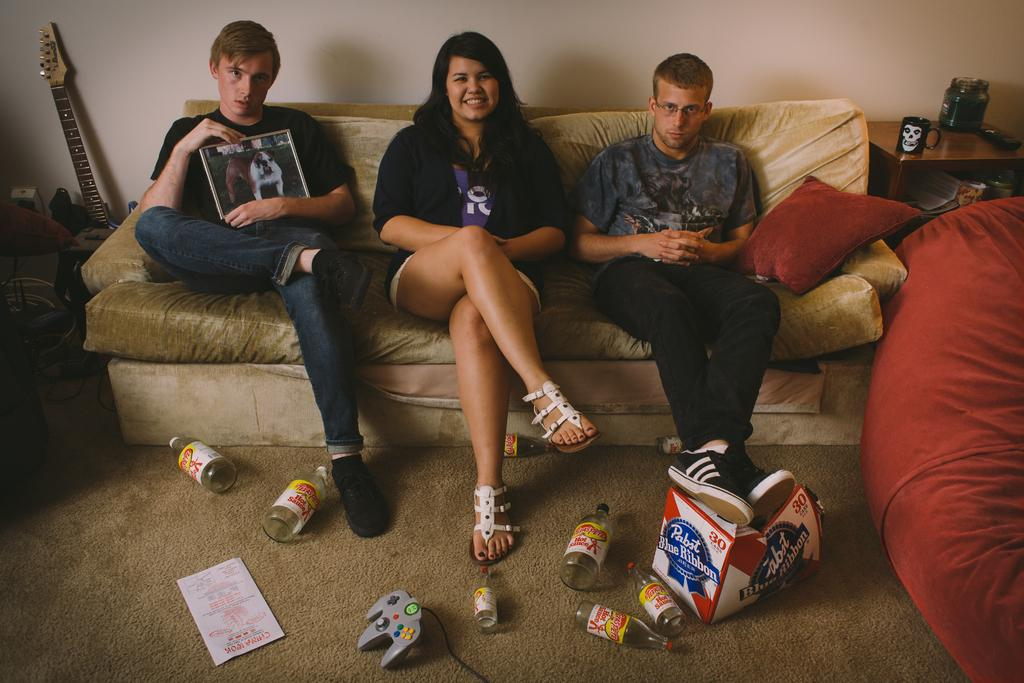<image>
Describe the image concisely. Three people sitting on a couch with a box of Pabst Blue ribbon beer on the floor 